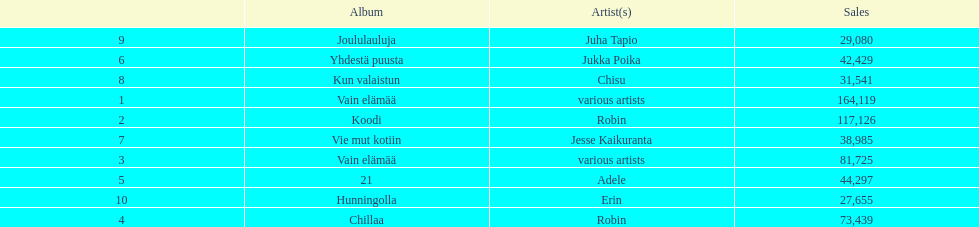Which was the last album to sell over 100,000 records? Koodi. 